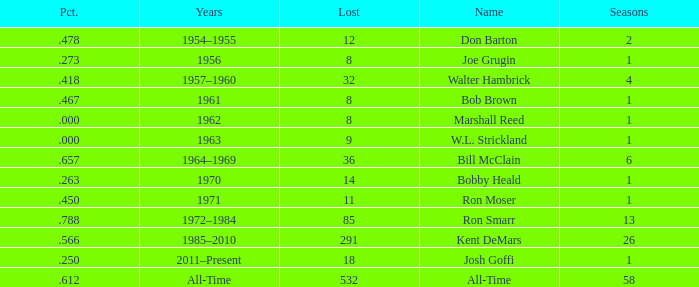Which Seasons has a Name of joe grugin, and a Lost larger than 8? 0.0. 